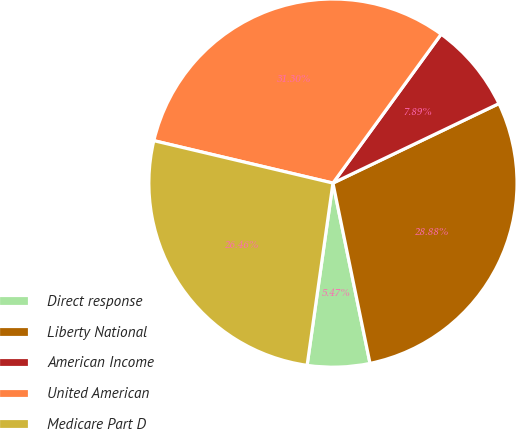Convert chart to OTSL. <chart><loc_0><loc_0><loc_500><loc_500><pie_chart><fcel>Direct response<fcel>Liberty National<fcel>American Income<fcel>United American<fcel>Medicare Part D<nl><fcel>5.47%<fcel>28.88%<fcel>7.89%<fcel>31.3%<fcel>26.46%<nl></chart> 